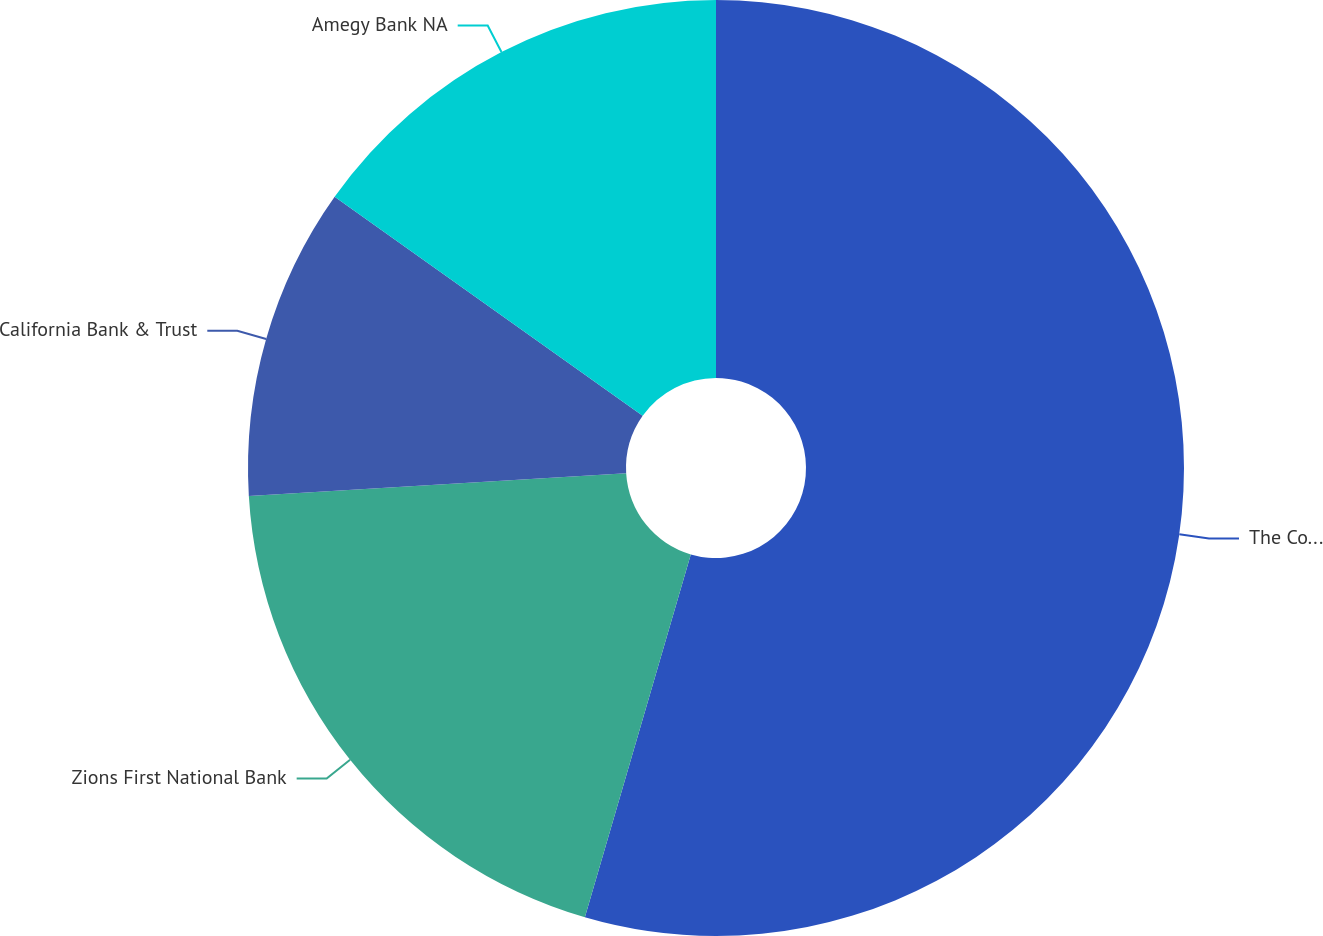Convert chart to OTSL. <chart><loc_0><loc_0><loc_500><loc_500><pie_chart><fcel>The Company<fcel>Zions First National Bank<fcel>California Bank & Trust<fcel>Amegy Bank NA<nl><fcel>54.52%<fcel>19.53%<fcel>10.79%<fcel>15.16%<nl></chart> 